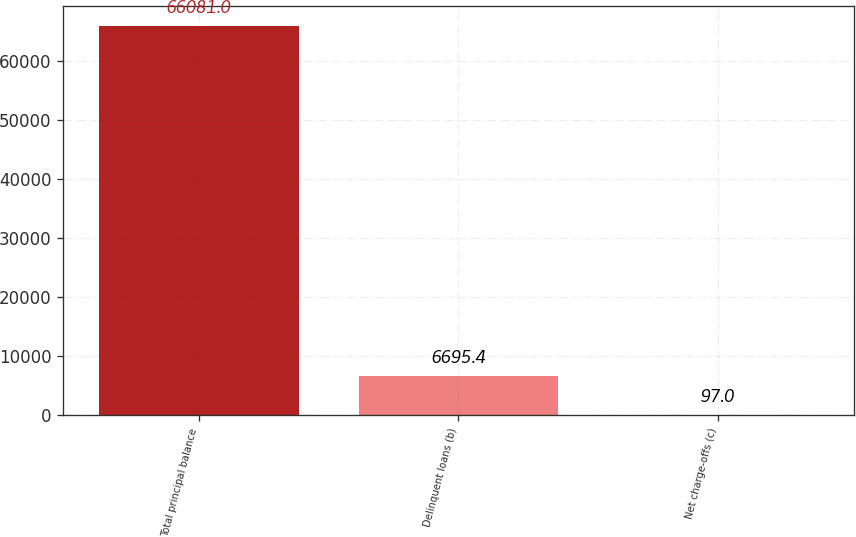Convert chart to OTSL. <chart><loc_0><loc_0><loc_500><loc_500><bar_chart><fcel>Total principal balance<fcel>Delinquent loans (b)<fcel>Net charge-offs (c)<nl><fcel>66081<fcel>6695.4<fcel>97<nl></chart> 